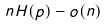<formula> <loc_0><loc_0><loc_500><loc_500>n H ( p ) - o ( n )</formula> 